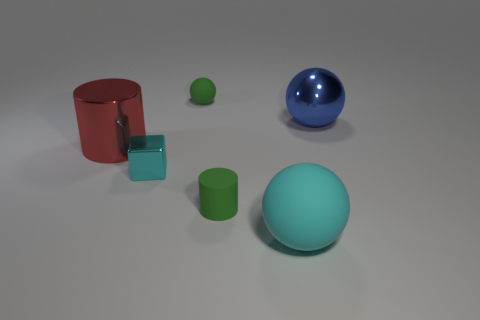What can you infer about the lighting and mood created in this scene? The lighting in this scene is soft and diffuse, producing gentle shadows and a serene ambiance. The absence of harsh light or stark contrasts gives the scene a calm and contemplative mood. It seems to mimic the diffuse light of an overcast day, where colors maintain their depth without being washed out, evoking a sense of tranquility and balance. 